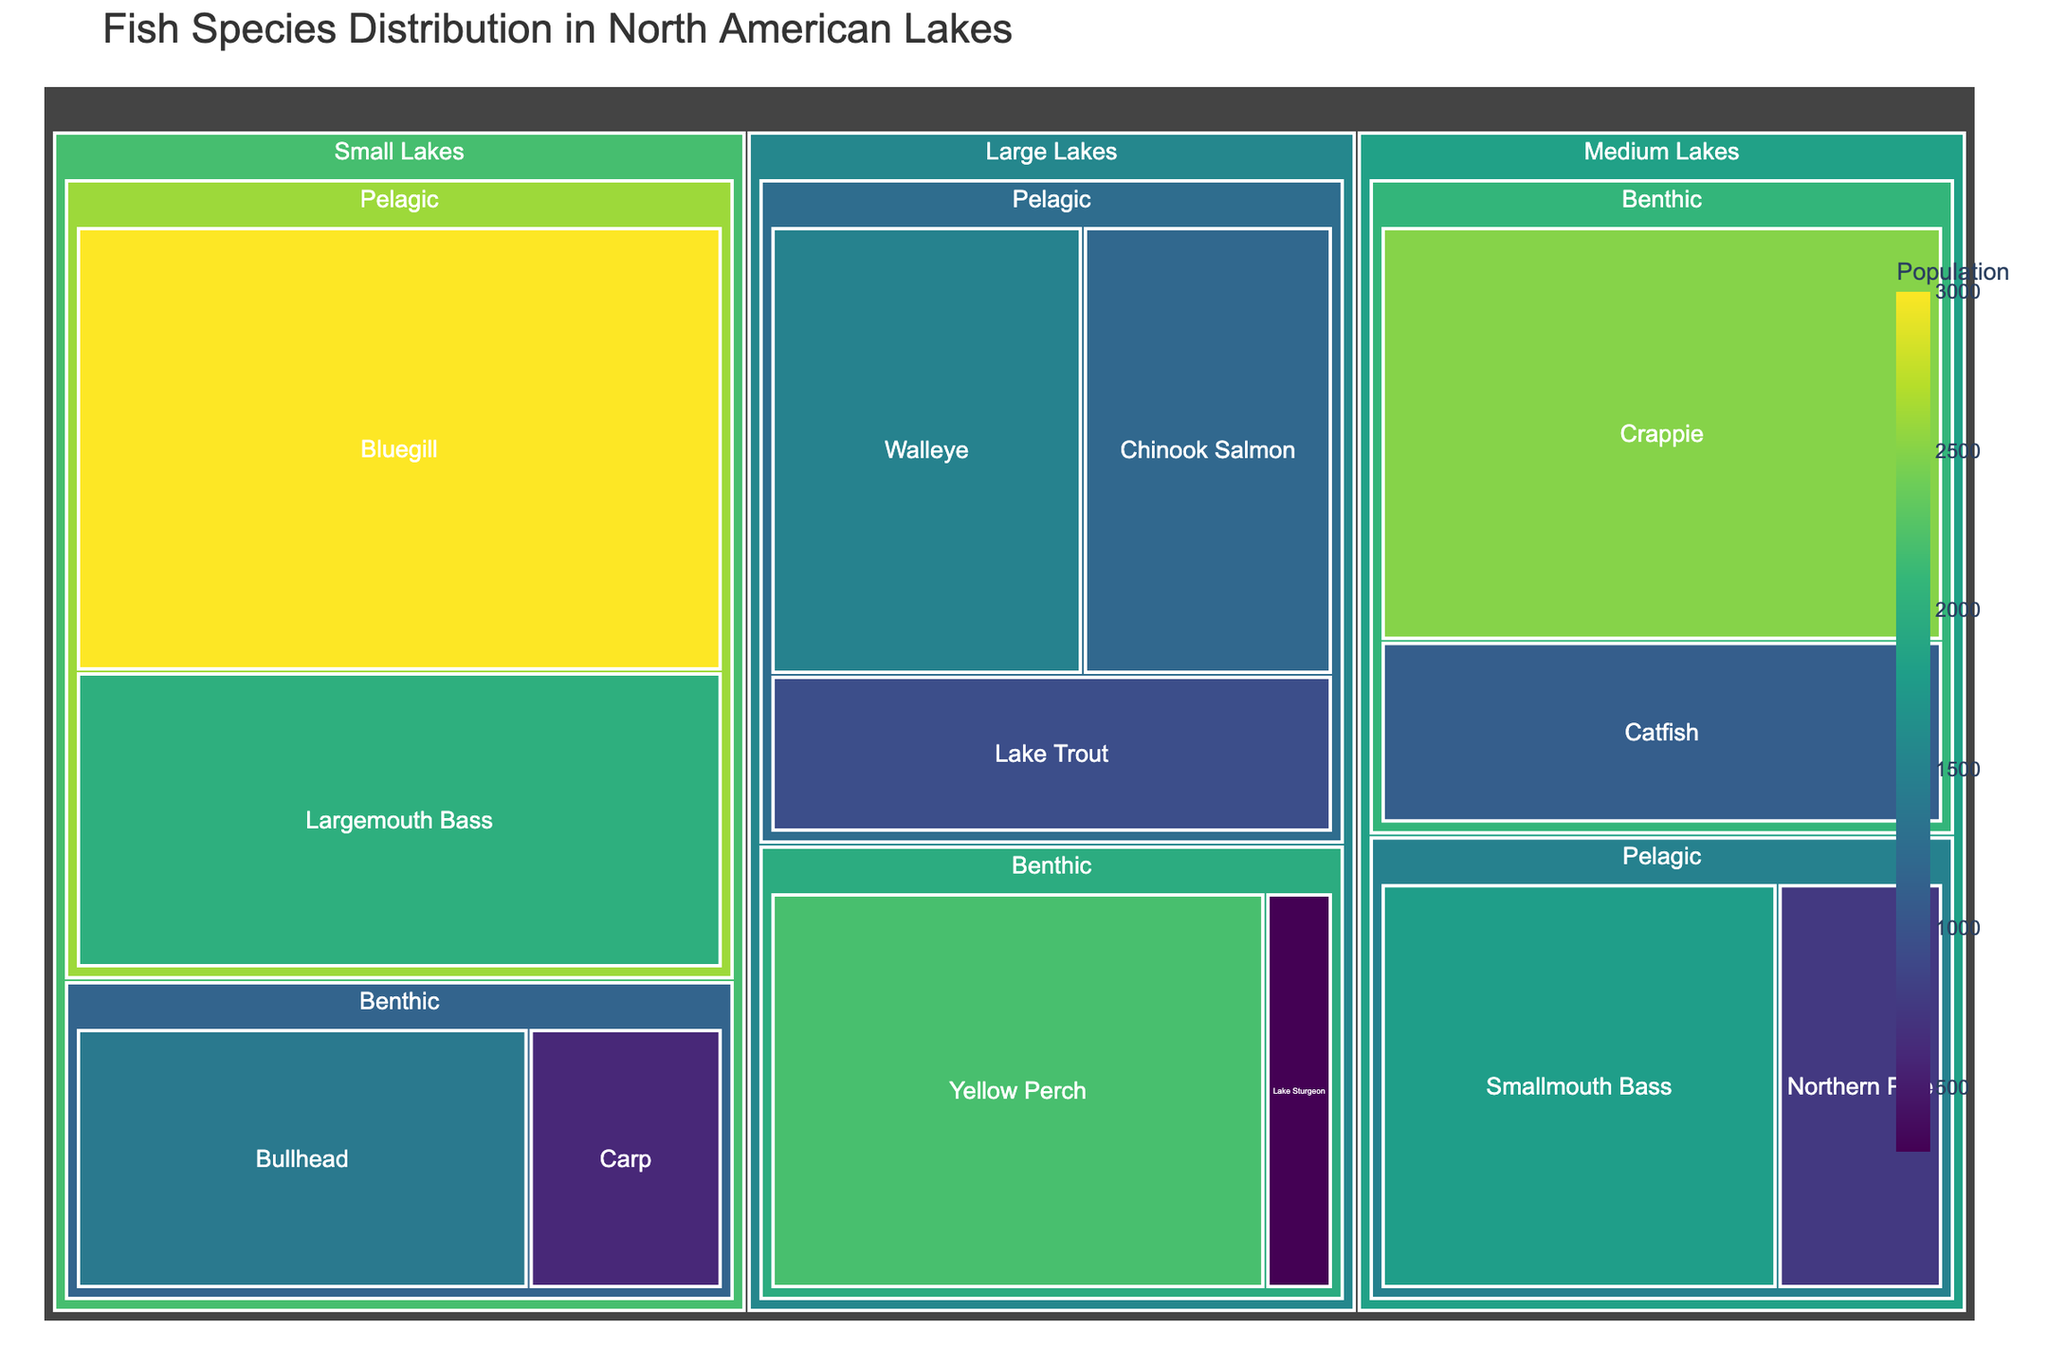What's the title of the figure? The title of the figure is located at the top of the treemap and describes the main topic the figure represents.
Answer: Fish Species Distribution in North American Lakes What is the species with the highest population in the Small Lakes/Pelagic category? Locate the Small Lakes category, then within it, the Pelagic subcategory. Identify the species with the highest population indicated by the largest area and most intense color.
Answer: Bluegill Which category has the largest overall population? Compare the overall areas of the categories (Large Lakes, Medium Lakes, Small Lakes). The largest category by area and color intensity indicates the highest population.
Answer: Small Lakes How many species are represented in the Large Lakes category? Count each species under both subcategories (Pelagic and Benthic) within the Large Lakes category.
Answer: 5 What is the combined population of the Chinook Salmon and Lake Trout in Large Lakes/Pelagic? Identify the population for Chinook Salmon and Lake Trout, then sum these numbers: 1200 (Chinook Salmon) + 950 (Lake Trout).
Answer: 2150 How does the population of Yellow Perch in Large Lakes/Benthic compare to the population of Largemouth Bass in Small Lakes/Pelagic? Locate and compare the population figures. Yellow Perch (2200) and Largemouth Bass (2000).
Answer: Yellow Perch has a higher population than Largemouth Bass Which habitat and size category has the smallest fish population? Identify the smallest area and least intense color among all categories and subcategories.
Answer: Small Lakes/Benthic What is the population difference between Walleye in Large Lakes/Pelagic and Smallmouth Bass in Medium Lakes/Pelagic? Subtract the population of Smallmouth Bass (1800) from Walleye (1500).
Answer: -300 What is the ratio of Catfish in Medium Lakes/Benthic to Carp in Small Lakes/Benthic? Identify the populations of Catfish (1100) and Carp (600). Then divide Catfish by Carp: 1100/600.
Answer: 11:6 Which species in Medium Lakes/Benthic have the highest population? Locate the Medium Lakes category, within it the Benthic subcategory. Compare species populations to identify the highest one.
Answer: Crappie 